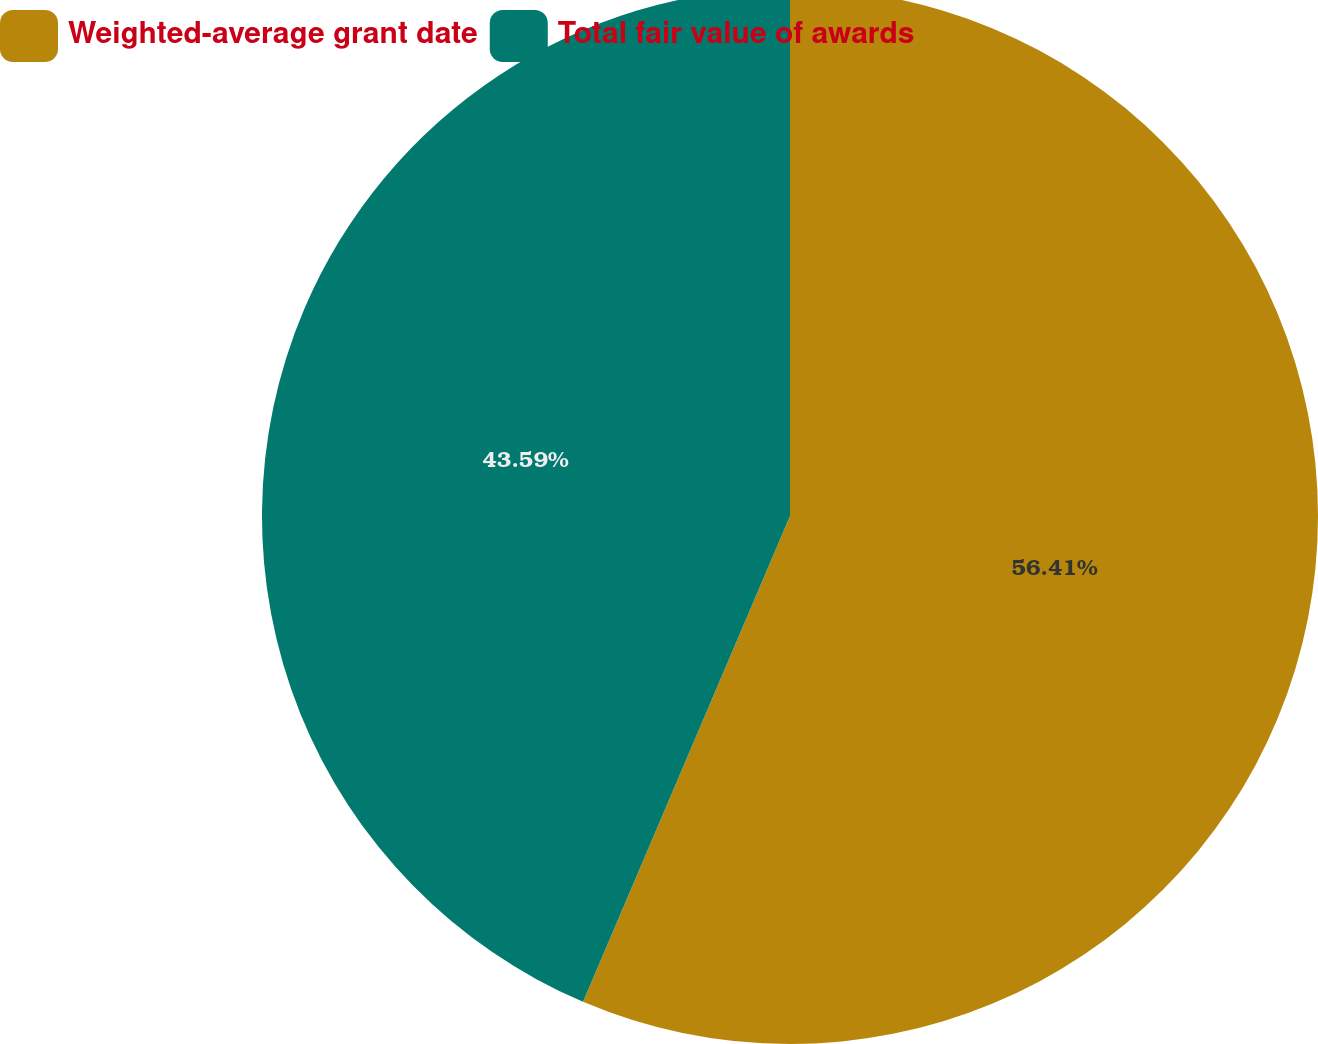Convert chart. <chart><loc_0><loc_0><loc_500><loc_500><pie_chart><fcel>Weighted-average grant date<fcel>Total fair value of awards<nl><fcel>56.41%<fcel>43.59%<nl></chart> 